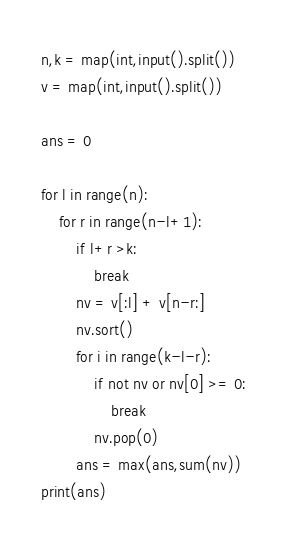Convert code to text. <code><loc_0><loc_0><loc_500><loc_500><_Python_>n,k = map(int,input().split())
v = map(int,input().split())

ans = 0

for l in range(n):
    for r in range(n-l+1):
        if l+r >k:
            break
        nv = v[:l] + v[n-r:]
        nv.sort()
        for i in range(k-l-r):
            if not nv or nv[0] >= 0:
                break
            nv.pop(0)
        ans = max(ans,sum(nv))
print(ans)
</code> 